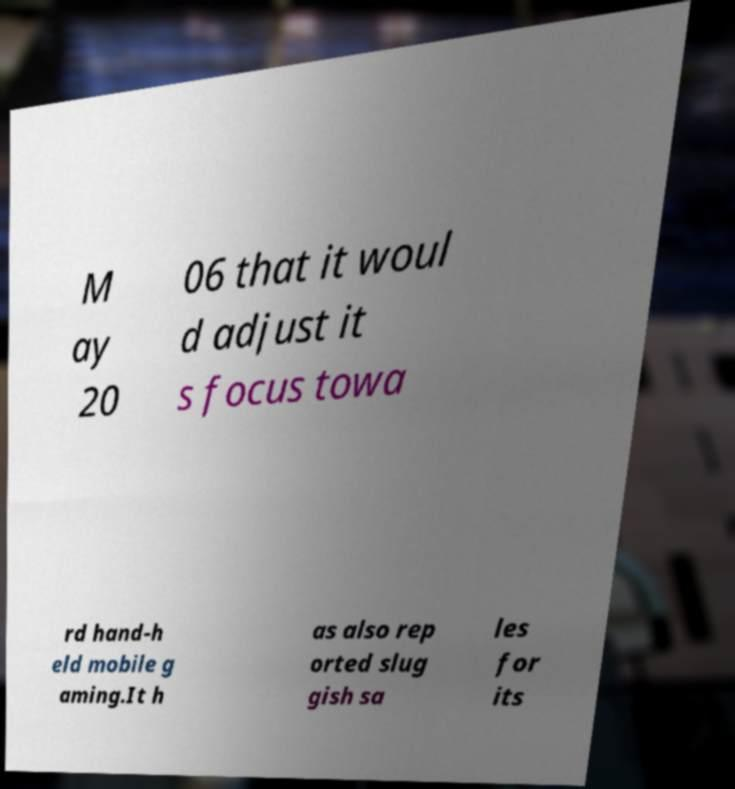Please identify and transcribe the text found in this image. M ay 20 06 that it woul d adjust it s focus towa rd hand-h eld mobile g aming.It h as also rep orted slug gish sa les for its 